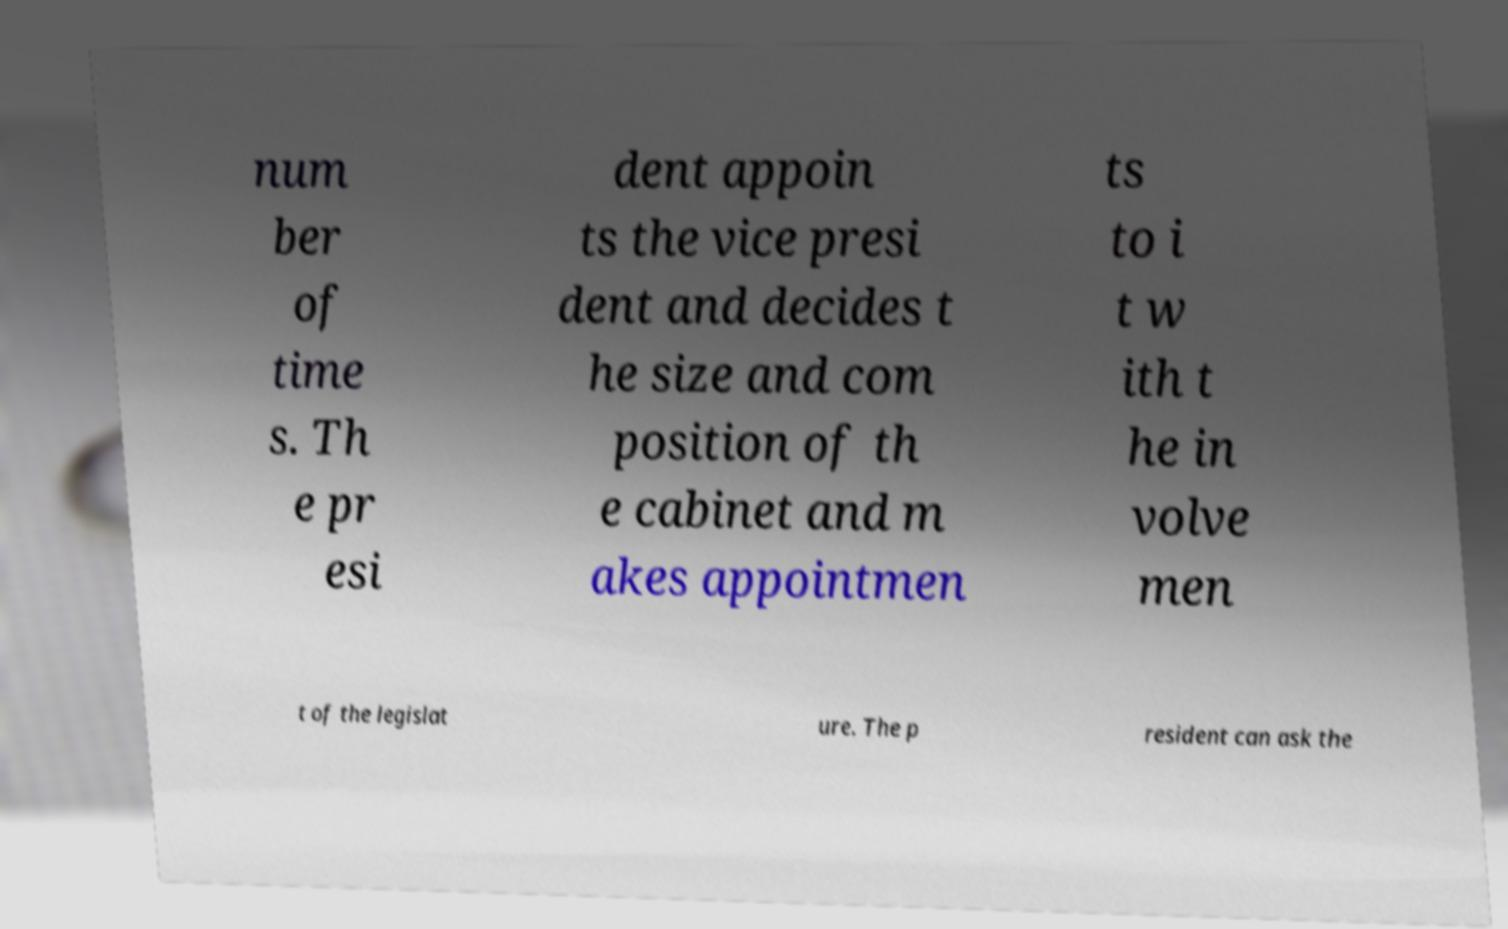Could you extract and type out the text from this image? num ber of time s. Th e pr esi dent appoin ts the vice presi dent and decides t he size and com position of th e cabinet and m akes appointmen ts to i t w ith t he in volve men t of the legislat ure. The p resident can ask the 